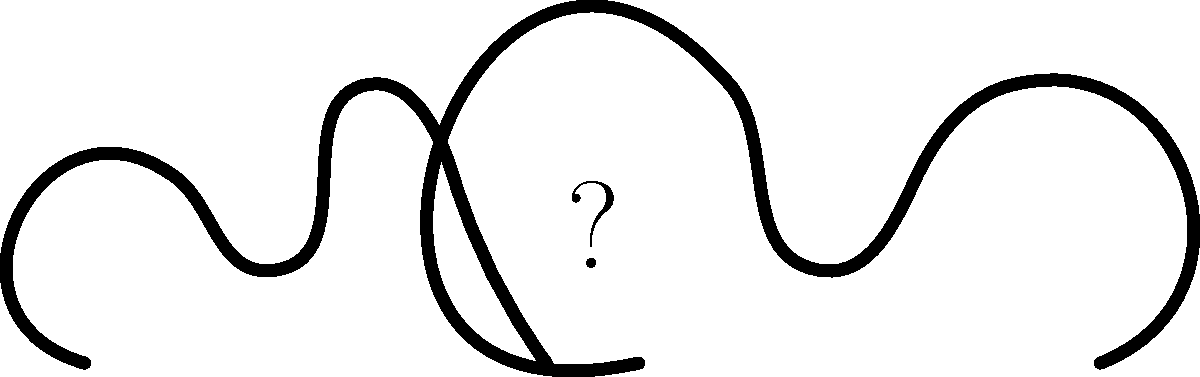Can you identify the celebrity couple represented by these silhouettes, who recently made headlines with their high-profile divorce after years of marriage? To identify the celebrity couple from the silhouettes, let's break down the clues:

1. The silhouettes suggest a male and female figure, indicating a heterosexual couple.
2. The question mentions a "high-profile divorce," implying a well-known celebrity couple.
3. The phrase "after years of marriage" suggests a long-term relationship.
4. Recent headlines about celebrity divorces are key to solving this puzzle.

Considering these factors, the most likely answer is Kim Kardashian and Kanye West. Here's why:

1. Their divorce was highly publicized in 2021-2022.
2. They were married for nearly 7 years (2014-2022), fitting the "years of marriage" description.
3. Both are extremely famous, making their split a "high-profile divorce."
4. Their relationship and divorce generated significant media attention and scandal, appealing to those interested in celebrity gossip.

The silhouettes, while not exact representations, could be interpreted as Kim Kardashian's curvy figure and Kanye West's distinctive profile.
Answer: Kim Kardashian and Kanye West 